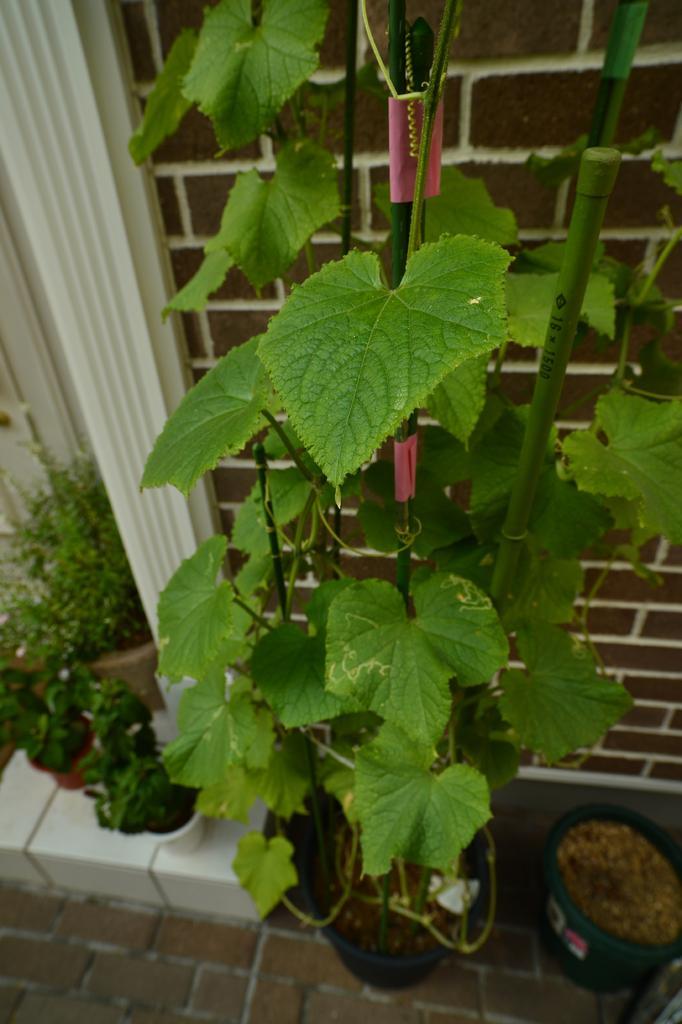Describe this image in one or two sentences. In this image in the foreground there is a plant, and at the bottom there are some flower pots, plants and sand and a walkway and in the background there is wall. 